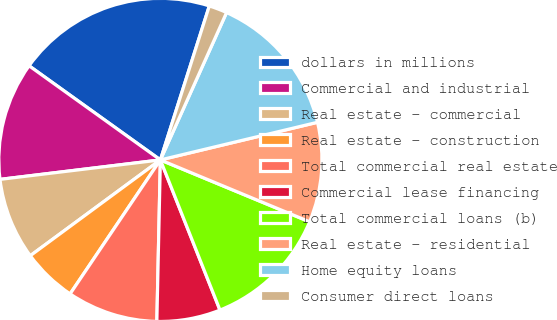Convert chart. <chart><loc_0><loc_0><loc_500><loc_500><pie_chart><fcel>dollars in millions<fcel>Commercial and industrial<fcel>Real estate - commercial<fcel>Real estate - construction<fcel>Total commercial real estate<fcel>Commercial lease financing<fcel>Total commercial loans (b)<fcel>Real estate - residential<fcel>Home equity loans<fcel>Consumer direct loans<nl><fcel>20.0%<fcel>11.82%<fcel>8.18%<fcel>5.46%<fcel>9.09%<fcel>6.36%<fcel>12.73%<fcel>10.0%<fcel>14.54%<fcel>1.82%<nl></chart> 